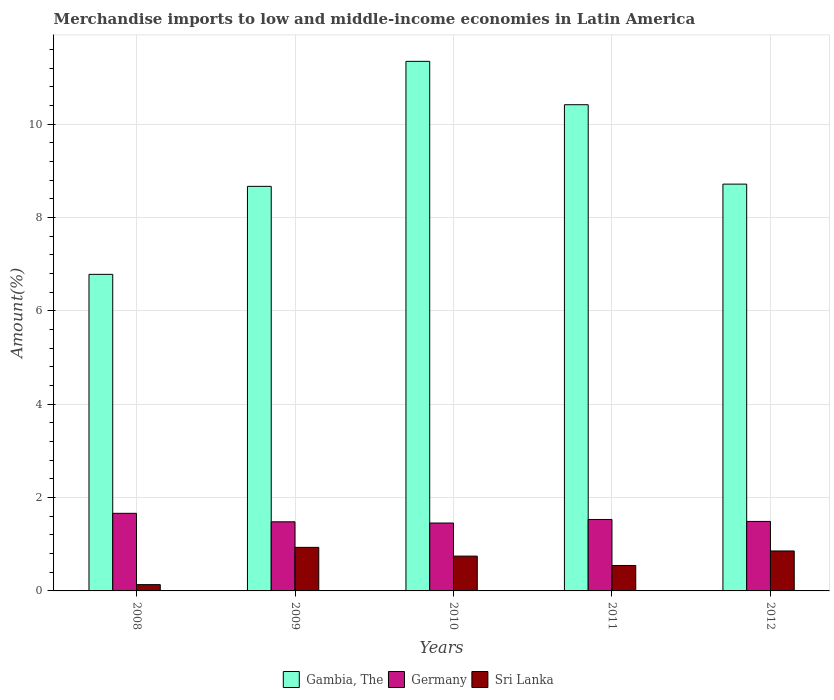How many different coloured bars are there?
Your answer should be very brief. 3. Are the number of bars on each tick of the X-axis equal?
Provide a succinct answer. Yes. What is the label of the 5th group of bars from the left?
Your answer should be compact. 2012. What is the percentage of amount earned from merchandise imports in Gambia, The in 2011?
Provide a succinct answer. 10.42. Across all years, what is the maximum percentage of amount earned from merchandise imports in Gambia, The?
Your answer should be very brief. 11.35. Across all years, what is the minimum percentage of amount earned from merchandise imports in Gambia, The?
Keep it short and to the point. 6.78. In which year was the percentage of amount earned from merchandise imports in Germany minimum?
Offer a terse response. 2010. What is the total percentage of amount earned from merchandise imports in Germany in the graph?
Your answer should be very brief. 7.62. What is the difference between the percentage of amount earned from merchandise imports in Germany in 2008 and that in 2012?
Keep it short and to the point. 0.17. What is the difference between the percentage of amount earned from merchandise imports in Gambia, The in 2011 and the percentage of amount earned from merchandise imports in Sri Lanka in 2012?
Ensure brevity in your answer.  9.56. What is the average percentage of amount earned from merchandise imports in Gambia, The per year?
Your response must be concise. 9.19. In the year 2010, what is the difference between the percentage of amount earned from merchandise imports in Gambia, The and percentage of amount earned from merchandise imports in Sri Lanka?
Provide a succinct answer. 10.6. In how many years, is the percentage of amount earned from merchandise imports in Gambia, The greater than 2.8 %?
Your answer should be compact. 5. What is the ratio of the percentage of amount earned from merchandise imports in Sri Lanka in 2008 to that in 2012?
Offer a terse response. 0.16. Is the percentage of amount earned from merchandise imports in Sri Lanka in 2008 less than that in 2010?
Provide a succinct answer. Yes. What is the difference between the highest and the second highest percentage of amount earned from merchandise imports in Germany?
Provide a succinct answer. 0.13. What is the difference between the highest and the lowest percentage of amount earned from merchandise imports in Germany?
Your response must be concise. 0.21. What does the 1st bar from the right in 2012 represents?
Your answer should be very brief. Sri Lanka. Is it the case that in every year, the sum of the percentage of amount earned from merchandise imports in Gambia, The and percentage of amount earned from merchandise imports in Germany is greater than the percentage of amount earned from merchandise imports in Sri Lanka?
Your answer should be very brief. Yes. Are all the bars in the graph horizontal?
Your response must be concise. No. How many years are there in the graph?
Offer a terse response. 5. Are the values on the major ticks of Y-axis written in scientific E-notation?
Offer a very short reply. No. Does the graph contain any zero values?
Make the answer very short. No. Does the graph contain grids?
Offer a terse response. Yes. How many legend labels are there?
Provide a short and direct response. 3. How are the legend labels stacked?
Your response must be concise. Horizontal. What is the title of the graph?
Your response must be concise. Merchandise imports to low and middle-income economies in Latin America. What is the label or title of the Y-axis?
Provide a short and direct response. Amount(%). What is the Amount(%) in Gambia, The in 2008?
Offer a very short reply. 6.78. What is the Amount(%) of Germany in 2008?
Your answer should be compact. 1.66. What is the Amount(%) of Sri Lanka in 2008?
Offer a terse response. 0.13. What is the Amount(%) in Gambia, The in 2009?
Give a very brief answer. 8.67. What is the Amount(%) of Germany in 2009?
Make the answer very short. 1.48. What is the Amount(%) in Sri Lanka in 2009?
Ensure brevity in your answer.  0.93. What is the Amount(%) in Gambia, The in 2010?
Keep it short and to the point. 11.35. What is the Amount(%) of Germany in 2010?
Give a very brief answer. 1.45. What is the Amount(%) in Sri Lanka in 2010?
Your response must be concise. 0.75. What is the Amount(%) in Gambia, The in 2011?
Offer a terse response. 10.42. What is the Amount(%) of Germany in 2011?
Your answer should be compact. 1.53. What is the Amount(%) in Sri Lanka in 2011?
Ensure brevity in your answer.  0.55. What is the Amount(%) of Gambia, The in 2012?
Keep it short and to the point. 8.72. What is the Amount(%) in Germany in 2012?
Offer a terse response. 1.49. What is the Amount(%) in Sri Lanka in 2012?
Your answer should be very brief. 0.86. Across all years, what is the maximum Amount(%) of Gambia, The?
Keep it short and to the point. 11.35. Across all years, what is the maximum Amount(%) of Germany?
Your answer should be very brief. 1.66. Across all years, what is the maximum Amount(%) of Sri Lanka?
Your answer should be very brief. 0.93. Across all years, what is the minimum Amount(%) of Gambia, The?
Your answer should be compact. 6.78. Across all years, what is the minimum Amount(%) in Germany?
Keep it short and to the point. 1.45. Across all years, what is the minimum Amount(%) in Sri Lanka?
Ensure brevity in your answer.  0.13. What is the total Amount(%) of Gambia, The in the graph?
Ensure brevity in your answer.  45.93. What is the total Amount(%) in Germany in the graph?
Give a very brief answer. 7.62. What is the total Amount(%) of Sri Lanka in the graph?
Make the answer very short. 3.22. What is the difference between the Amount(%) of Gambia, The in 2008 and that in 2009?
Your answer should be very brief. -1.89. What is the difference between the Amount(%) in Germany in 2008 and that in 2009?
Your response must be concise. 0.18. What is the difference between the Amount(%) of Sri Lanka in 2008 and that in 2009?
Offer a very short reply. -0.8. What is the difference between the Amount(%) of Gambia, The in 2008 and that in 2010?
Your response must be concise. -4.56. What is the difference between the Amount(%) in Germany in 2008 and that in 2010?
Provide a succinct answer. 0.21. What is the difference between the Amount(%) of Sri Lanka in 2008 and that in 2010?
Provide a short and direct response. -0.61. What is the difference between the Amount(%) in Gambia, The in 2008 and that in 2011?
Provide a succinct answer. -3.63. What is the difference between the Amount(%) of Germany in 2008 and that in 2011?
Provide a succinct answer. 0.13. What is the difference between the Amount(%) in Sri Lanka in 2008 and that in 2011?
Ensure brevity in your answer.  -0.41. What is the difference between the Amount(%) of Gambia, The in 2008 and that in 2012?
Your answer should be very brief. -1.93. What is the difference between the Amount(%) in Germany in 2008 and that in 2012?
Ensure brevity in your answer.  0.17. What is the difference between the Amount(%) in Sri Lanka in 2008 and that in 2012?
Provide a succinct answer. -0.72. What is the difference between the Amount(%) in Gambia, The in 2009 and that in 2010?
Keep it short and to the point. -2.68. What is the difference between the Amount(%) of Germany in 2009 and that in 2010?
Ensure brevity in your answer.  0.03. What is the difference between the Amount(%) of Sri Lanka in 2009 and that in 2010?
Provide a succinct answer. 0.19. What is the difference between the Amount(%) of Gambia, The in 2009 and that in 2011?
Make the answer very short. -1.75. What is the difference between the Amount(%) in Germany in 2009 and that in 2011?
Your response must be concise. -0.05. What is the difference between the Amount(%) of Sri Lanka in 2009 and that in 2011?
Provide a succinct answer. 0.39. What is the difference between the Amount(%) of Gambia, The in 2009 and that in 2012?
Offer a terse response. -0.05. What is the difference between the Amount(%) in Germany in 2009 and that in 2012?
Your answer should be very brief. -0.01. What is the difference between the Amount(%) in Sri Lanka in 2009 and that in 2012?
Make the answer very short. 0.08. What is the difference between the Amount(%) in Gambia, The in 2010 and that in 2011?
Provide a short and direct response. 0.93. What is the difference between the Amount(%) in Germany in 2010 and that in 2011?
Your answer should be very brief. -0.08. What is the difference between the Amount(%) of Sri Lanka in 2010 and that in 2011?
Give a very brief answer. 0.2. What is the difference between the Amount(%) of Gambia, The in 2010 and that in 2012?
Give a very brief answer. 2.63. What is the difference between the Amount(%) of Germany in 2010 and that in 2012?
Give a very brief answer. -0.03. What is the difference between the Amount(%) of Sri Lanka in 2010 and that in 2012?
Make the answer very short. -0.11. What is the difference between the Amount(%) of Gambia, The in 2011 and that in 2012?
Provide a short and direct response. 1.7. What is the difference between the Amount(%) in Germany in 2011 and that in 2012?
Your answer should be very brief. 0.04. What is the difference between the Amount(%) of Sri Lanka in 2011 and that in 2012?
Give a very brief answer. -0.31. What is the difference between the Amount(%) in Gambia, The in 2008 and the Amount(%) in Germany in 2009?
Your answer should be very brief. 5.3. What is the difference between the Amount(%) in Gambia, The in 2008 and the Amount(%) in Sri Lanka in 2009?
Give a very brief answer. 5.85. What is the difference between the Amount(%) in Germany in 2008 and the Amount(%) in Sri Lanka in 2009?
Give a very brief answer. 0.73. What is the difference between the Amount(%) of Gambia, The in 2008 and the Amount(%) of Germany in 2010?
Your answer should be very brief. 5.33. What is the difference between the Amount(%) in Gambia, The in 2008 and the Amount(%) in Sri Lanka in 2010?
Ensure brevity in your answer.  6.04. What is the difference between the Amount(%) in Germany in 2008 and the Amount(%) in Sri Lanka in 2010?
Your answer should be very brief. 0.92. What is the difference between the Amount(%) of Gambia, The in 2008 and the Amount(%) of Germany in 2011?
Your answer should be very brief. 5.25. What is the difference between the Amount(%) of Gambia, The in 2008 and the Amount(%) of Sri Lanka in 2011?
Ensure brevity in your answer.  6.24. What is the difference between the Amount(%) of Germany in 2008 and the Amount(%) of Sri Lanka in 2011?
Ensure brevity in your answer.  1.12. What is the difference between the Amount(%) of Gambia, The in 2008 and the Amount(%) of Germany in 2012?
Ensure brevity in your answer.  5.29. What is the difference between the Amount(%) of Gambia, The in 2008 and the Amount(%) of Sri Lanka in 2012?
Offer a very short reply. 5.93. What is the difference between the Amount(%) of Germany in 2008 and the Amount(%) of Sri Lanka in 2012?
Offer a very short reply. 0.81. What is the difference between the Amount(%) of Gambia, The in 2009 and the Amount(%) of Germany in 2010?
Ensure brevity in your answer.  7.21. What is the difference between the Amount(%) in Gambia, The in 2009 and the Amount(%) in Sri Lanka in 2010?
Provide a short and direct response. 7.92. What is the difference between the Amount(%) of Germany in 2009 and the Amount(%) of Sri Lanka in 2010?
Offer a terse response. 0.74. What is the difference between the Amount(%) of Gambia, The in 2009 and the Amount(%) of Germany in 2011?
Your response must be concise. 7.14. What is the difference between the Amount(%) in Gambia, The in 2009 and the Amount(%) in Sri Lanka in 2011?
Your answer should be very brief. 8.12. What is the difference between the Amount(%) in Germany in 2009 and the Amount(%) in Sri Lanka in 2011?
Your answer should be very brief. 0.94. What is the difference between the Amount(%) of Gambia, The in 2009 and the Amount(%) of Germany in 2012?
Give a very brief answer. 7.18. What is the difference between the Amount(%) of Gambia, The in 2009 and the Amount(%) of Sri Lanka in 2012?
Provide a succinct answer. 7.81. What is the difference between the Amount(%) of Germany in 2009 and the Amount(%) of Sri Lanka in 2012?
Provide a short and direct response. 0.62. What is the difference between the Amount(%) in Gambia, The in 2010 and the Amount(%) in Germany in 2011?
Offer a terse response. 9.82. What is the difference between the Amount(%) in Gambia, The in 2010 and the Amount(%) in Sri Lanka in 2011?
Make the answer very short. 10.8. What is the difference between the Amount(%) in Germany in 2010 and the Amount(%) in Sri Lanka in 2011?
Your answer should be compact. 0.91. What is the difference between the Amount(%) of Gambia, The in 2010 and the Amount(%) of Germany in 2012?
Your response must be concise. 9.86. What is the difference between the Amount(%) of Gambia, The in 2010 and the Amount(%) of Sri Lanka in 2012?
Provide a succinct answer. 10.49. What is the difference between the Amount(%) in Germany in 2010 and the Amount(%) in Sri Lanka in 2012?
Your answer should be compact. 0.6. What is the difference between the Amount(%) of Gambia, The in 2011 and the Amount(%) of Germany in 2012?
Provide a short and direct response. 8.93. What is the difference between the Amount(%) of Gambia, The in 2011 and the Amount(%) of Sri Lanka in 2012?
Your answer should be very brief. 9.56. What is the difference between the Amount(%) of Germany in 2011 and the Amount(%) of Sri Lanka in 2012?
Give a very brief answer. 0.67. What is the average Amount(%) of Gambia, The per year?
Keep it short and to the point. 9.19. What is the average Amount(%) of Germany per year?
Make the answer very short. 1.52. What is the average Amount(%) in Sri Lanka per year?
Offer a terse response. 0.64. In the year 2008, what is the difference between the Amount(%) in Gambia, The and Amount(%) in Germany?
Provide a short and direct response. 5.12. In the year 2008, what is the difference between the Amount(%) in Gambia, The and Amount(%) in Sri Lanka?
Provide a short and direct response. 6.65. In the year 2008, what is the difference between the Amount(%) in Germany and Amount(%) in Sri Lanka?
Offer a very short reply. 1.53. In the year 2009, what is the difference between the Amount(%) in Gambia, The and Amount(%) in Germany?
Make the answer very short. 7.19. In the year 2009, what is the difference between the Amount(%) of Gambia, The and Amount(%) of Sri Lanka?
Keep it short and to the point. 7.74. In the year 2009, what is the difference between the Amount(%) of Germany and Amount(%) of Sri Lanka?
Keep it short and to the point. 0.55. In the year 2010, what is the difference between the Amount(%) of Gambia, The and Amount(%) of Germany?
Make the answer very short. 9.89. In the year 2010, what is the difference between the Amount(%) in Gambia, The and Amount(%) in Sri Lanka?
Offer a terse response. 10.6. In the year 2010, what is the difference between the Amount(%) in Germany and Amount(%) in Sri Lanka?
Provide a short and direct response. 0.71. In the year 2011, what is the difference between the Amount(%) of Gambia, The and Amount(%) of Germany?
Provide a succinct answer. 8.89. In the year 2011, what is the difference between the Amount(%) of Gambia, The and Amount(%) of Sri Lanka?
Ensure brevity in your answer.  9.87. In the year 2011, what is the difference between the Amount(%) in Germany and Amount(%) in Sri Lanka?
Offer a very short reply. 0.99. In the year 2012, what is the difference between the Amount(%) in Gambia, The and Amount(%) in Germany?
Your answer should be very brief. 7.23. In the year 2012, what is the difference between the Amount(%) of Gambia, The and Amount(%) of Sri Lanka?
Make the answer very short. 7.86. In the year 2012, what is the difference between the Amount(%) in Germany and Amount(%) in Sri Lanka?
Provide a short and direct response. 0.63. What is the ratio of the Amount(%) of Gambia, The in 2008 to that in 2009?
Your answer should be compact. 0.78. What is the ratio of the Amount(%) in Germany in 2008 to that in 2009?
Give a very brief answer. 1.12. What is the ratio of the Amount(%) in Sri Lanka in 2008 to that in 2009?
Your answer should be compact. 0.14. What is the ratio of the Amount(%) of Gambia, The in 2008 to that in 2010?
Give a very brief answer. 0.6. What is the ratio of the Amount(%) in Germany in 2008 to that in 2010?
Your answer should be very brief. 1.14. What is the ratio of the Amount(%) in Sri Lanka in 2008 to that in 2010?
Keep it short and to the point. 0.18. What is the ratio of the Amount(%) of Gambia, The in 2008 to that in 2011?
Provide a short and direct response. 0.65. What is the ratio of the Amount(%) in Germany in 2008 to that in 2011?
Offer a terse response. 1.09. What is the ratio of the Amount(%) of Sri Lanka in 2008 to that in 2011?
Give a very brief answer. 0.25. What is the ratio of the Amount(%) of Gambia, The in 2008 to that in 2012?
Your answer should be compact. 0.78. What is the ratio of the Amount(%) of Germany in 2008 to that in 2012?
Offer a very short reply. 1.12. What is the ratio of the Amount(%) in Sri Lanka in 2008 to that in 2012?
Your response must be concise. 0.16. What is the ratio of the Amount(%) in Gambia, The in 2009 to that in 2010?
Offer a terse response. 0.76. What is the ratio of the Amount(%) of Germany in 2009 to that in 2010?
Provide a short and direct response. 1.02. What is the ratio of the Amount(%) of Sri Lanka in 2009 to that in 2010?
Your response must be concise. 1.25. What is the ratio of the Amount(%) in Gambia, The in 2009 to that in 2011?
Your response must be concise. 0.83. What is the ratio of the Amount(%) of Germany in 2009 to that in 2011?
Your answer should be compact. 0.97. What is the ratio of the Amount(%) of Sri Lanka in 2009 to that in 2011?
Make the answer very short. 1.71. What is the ratio of the Amount(%) in Sri Lanka in 2009 to that in 2012?
Your response must be concise. 1.09. What is the ratio of the Amount(%) of Gambia, The in 2010 to that in 2011?
Offer a terse response. 1.09. What is the ratio of the Amount(%) of Germany in 2010 to that in 2011?
Offer a terse response. 0.95. What is the ratio of the Amount(%) in Sri Lanka in 2010 to that in 2011?
Make the answer very short. 1.37. What is the ratio of the Amount(%) of Gambia, The in 2010 to that in 2012?
Ensure brevity in your answer.  1.3. What is the ratio of the Amount(%) in Germany in 2010 to that in 2012?
Ensure brevity in your answer.  0.98. What is the ratio of the Amount(%) of Sri Lanka in 2010 to that in 2012?
Your answer should be compact. 0.87. What is the ratio of the Amount(%) of Gambia, The in 2011 to that in 2012?
Provide a short and direct response. 1.2. What is the ratio of the Amount(%) in Germany in 2011 to that in 2012?
Provide a short and direct response. 1.03. What is the ratio of the Amount(%) of Sri Lanka in 2011 to that in 2012?
Ensure brevity in your answer.  0.64. What is the difference between the highest and the second highest Amount(%) of Gambia, The?
Offer a terse response. 0.93. What is the difference between the highest and the second highest Amount(%) in Germany?
Keep it short and to the point. 0.13. What is the difference between the highest and the second highest Amount(%) of Sri Lanka?
Make the answer very short. 0.08. What is the difference between the highest and the lowest Amount(%) of Gambia, The?
Provide a short and direct response. 4.56. What is the difference between the highest and the lowest Amount(%) of Germany?
Make the answer very short. 0.21. What is the difference between the highest and the lowest Amount(%) of Sri Lanka?
Your answer should be very brief. 0.8. 